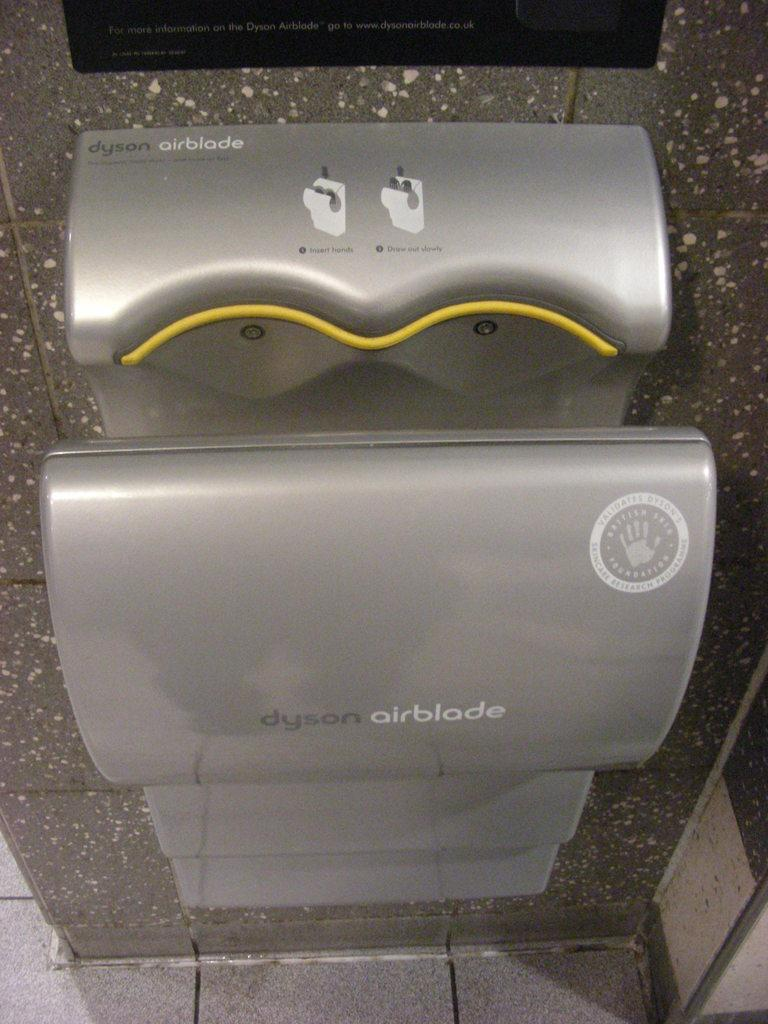<image>
Render a clear and concise summary of the photo. Gray hand dryer with the name Dyson Airblade on it. 